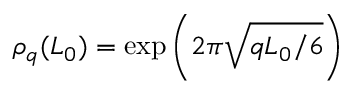Convert formula to latex. <formula><loc_0><loc_0><loc_500><loc_500>\rho _ { q } ( L _ { 0 } ) = \exp \left ( 2 \pi \sqrt { q L _ { 0 } / 6 } \right )</formula> 